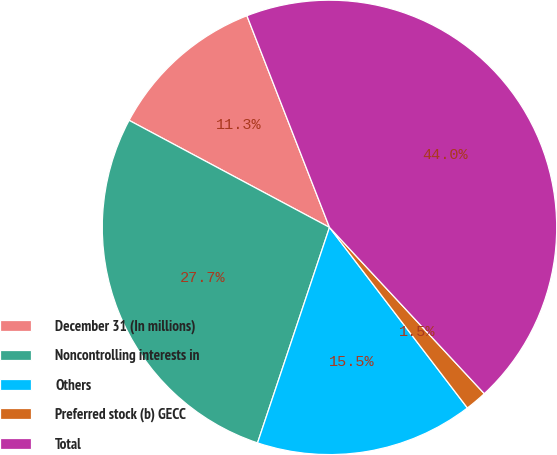Convert chart to OTSL. <chart><loc_0><loc_0><loc_500><loc_500><pie_chart><fcel>December 31 (In millions)<fcel>Noncontrolling interests in<fcel>Others<fcel>Preferred stock (b) GECC<fcel>Total<nl><fcel>11.27%<fcel>27.68%<fcel>15.51%<fcel>1.55%<fcel>43.99%<nl></chart> 